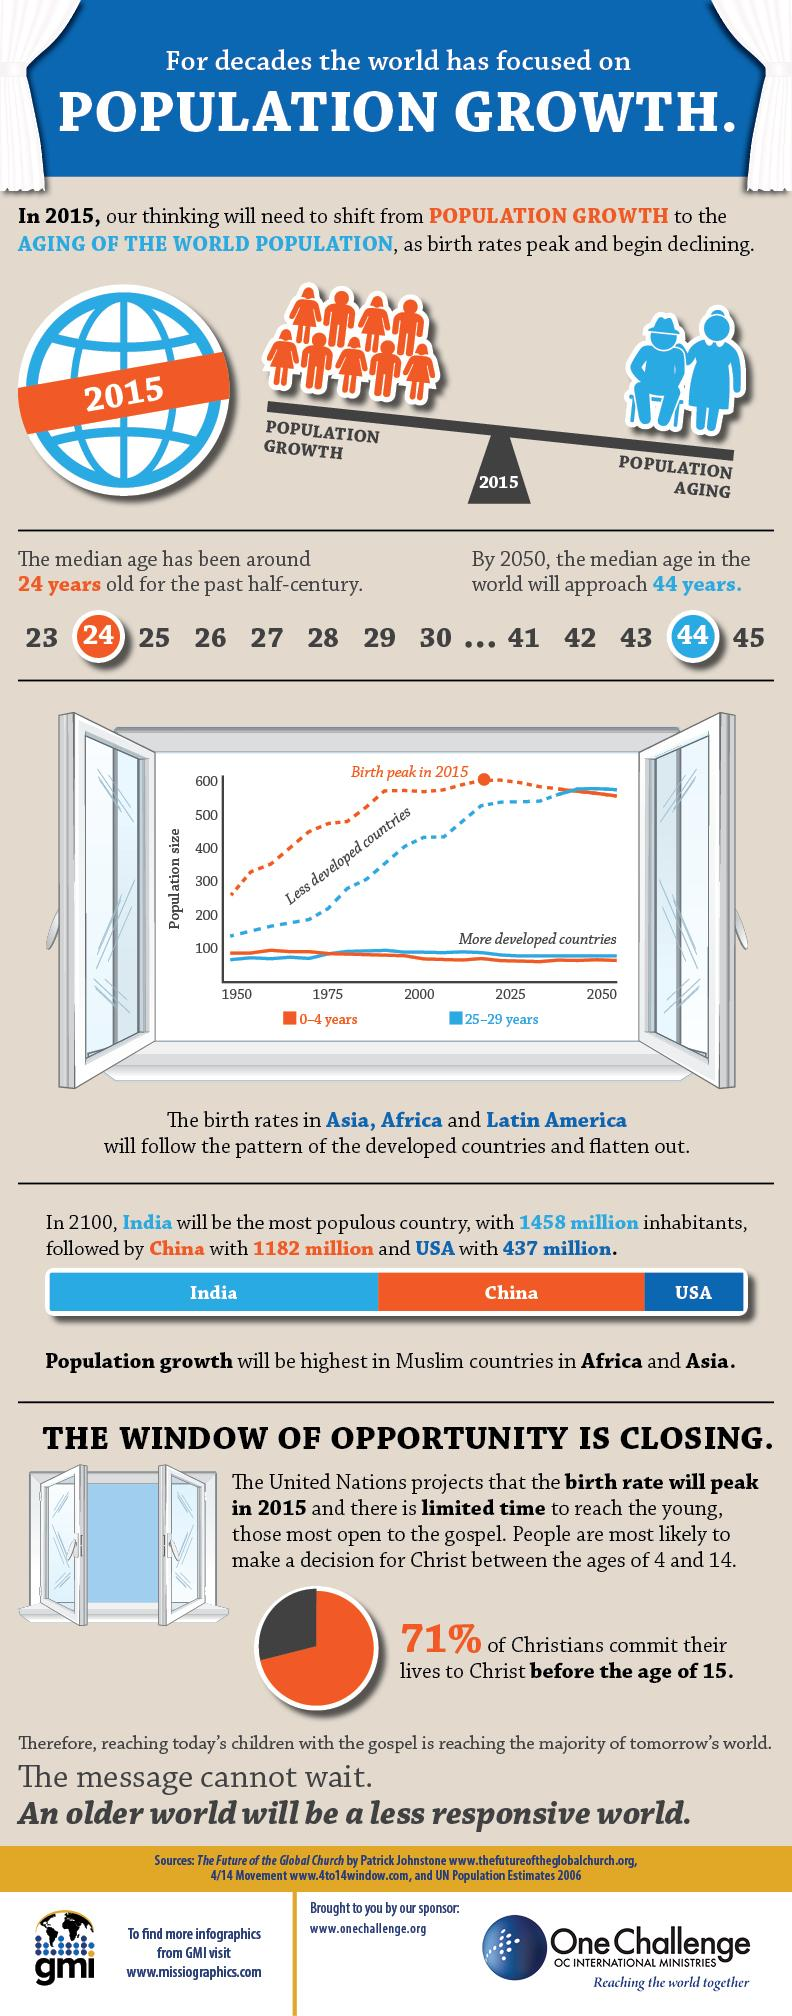Draw attention to some important aspects in this diagram. A large percentage of Christians did not commit their lives to Christ before the age of 15, which is 29%. 